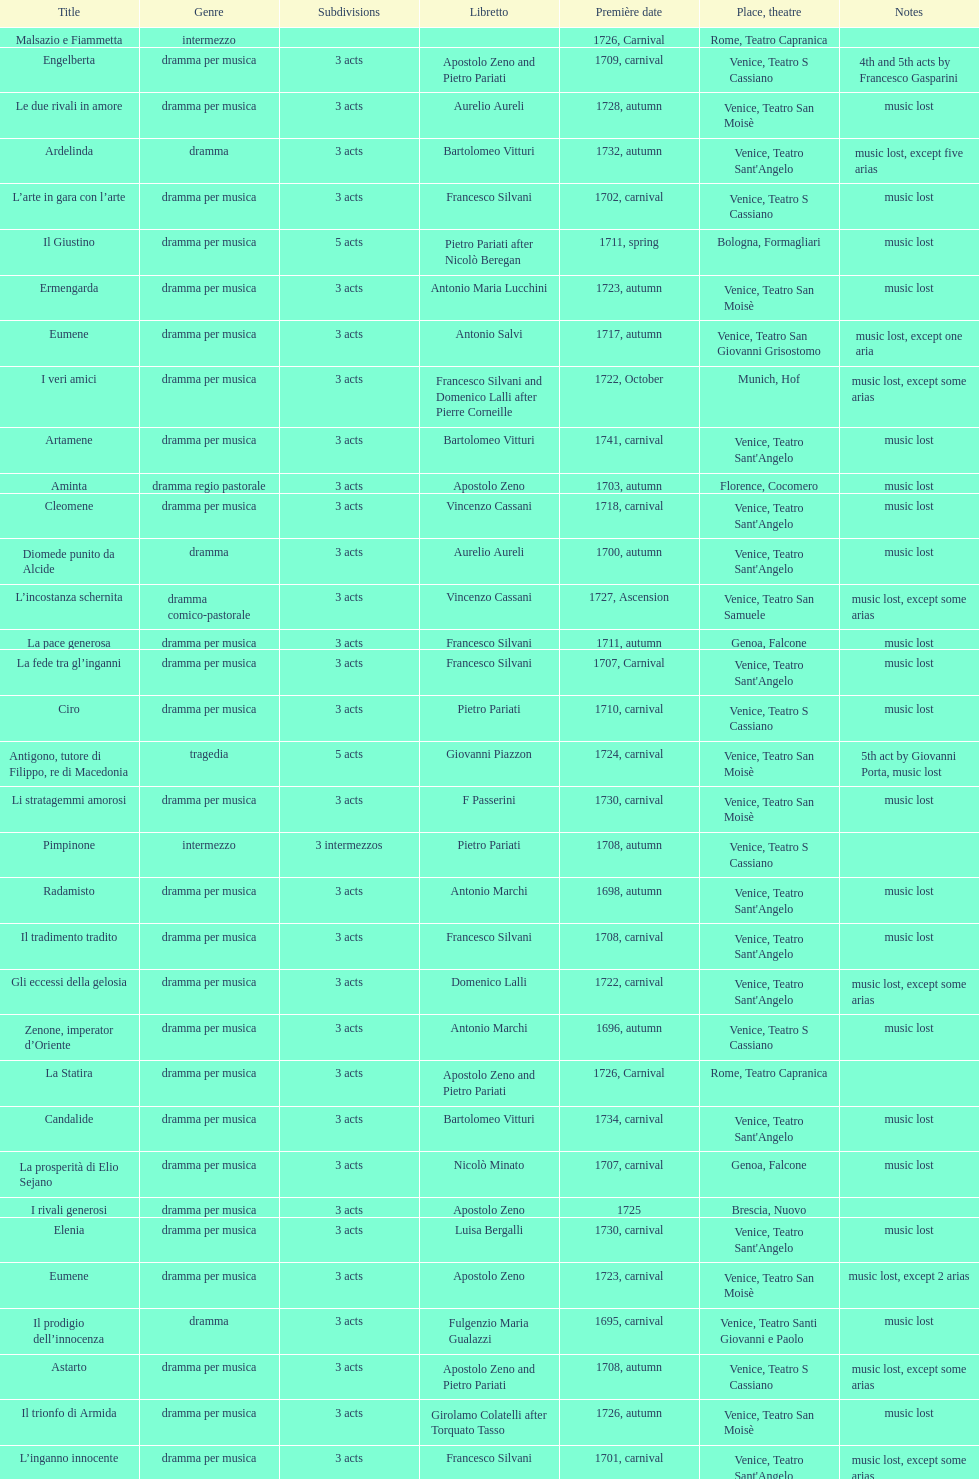Which title premiered directly after candalide? Artamene. 